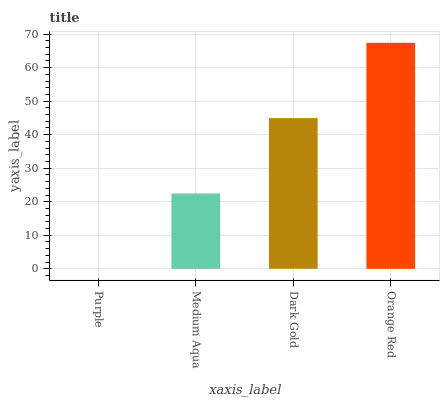Is Purple the minimum?
Answer yes or no. Yes. Is Orange Red the maximum?
Answer yes or no. Yes. Is Medium Aqua the minimum?
Answer yes or no. No. Is Medium Aqua the maximum?
Answer yes or no. No. Is Medium Aqua greater than Purple?
Answer yes or no. Yes. Is Purple less than Medium Aqua?
Answer yes or no. Yes. Is Purple greater than Medium Aqua?
Answer yes or no. No. Is Medium Aqua less than Purple?
Answer yes or no. No. Is Dark Gold the high median?
Answer yes or no. Yes. Is Medium Aqua the low median?
Answer yes or no. Yes. Is Purple the high median?
Answer yes or no. No. Is Dark Gold the low median?
Answer yes or no. No. 